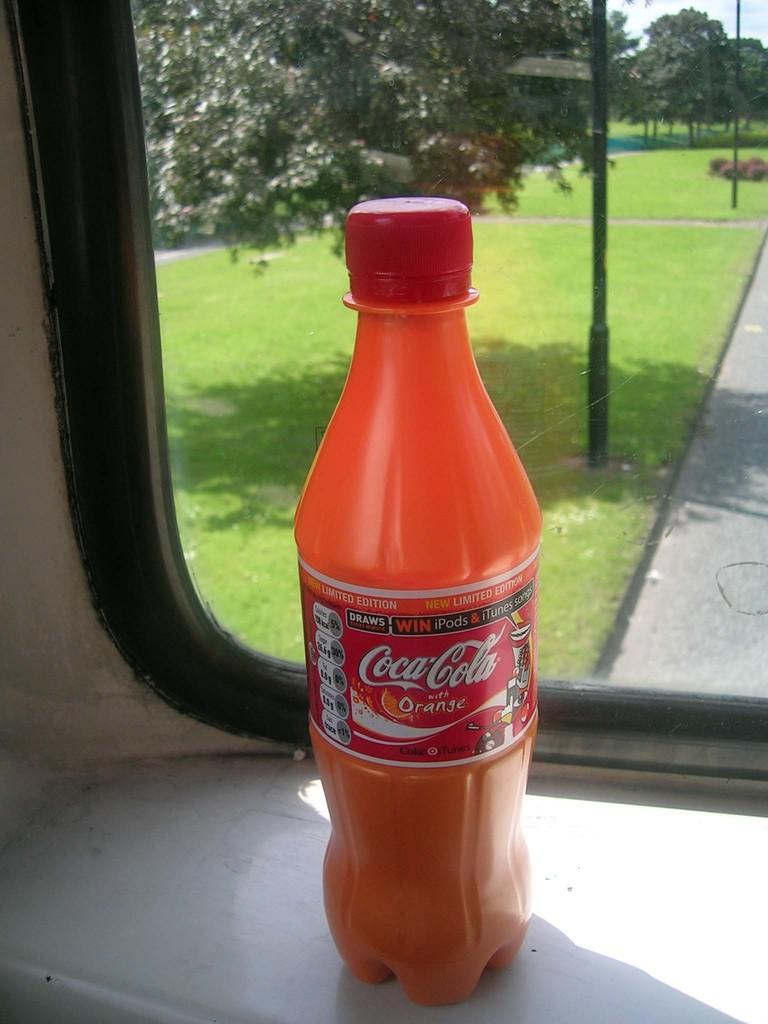<image>
Summarize the visual content of the image. A bottle of orange flavored Coca-Cola rests next to a window. 